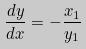<formula> <loc_0><loc_0><loc_500><loc_500>\frac { d y } { d x } = - \frac { x _ { 1 } } { y _ { 1 } }</formula> 